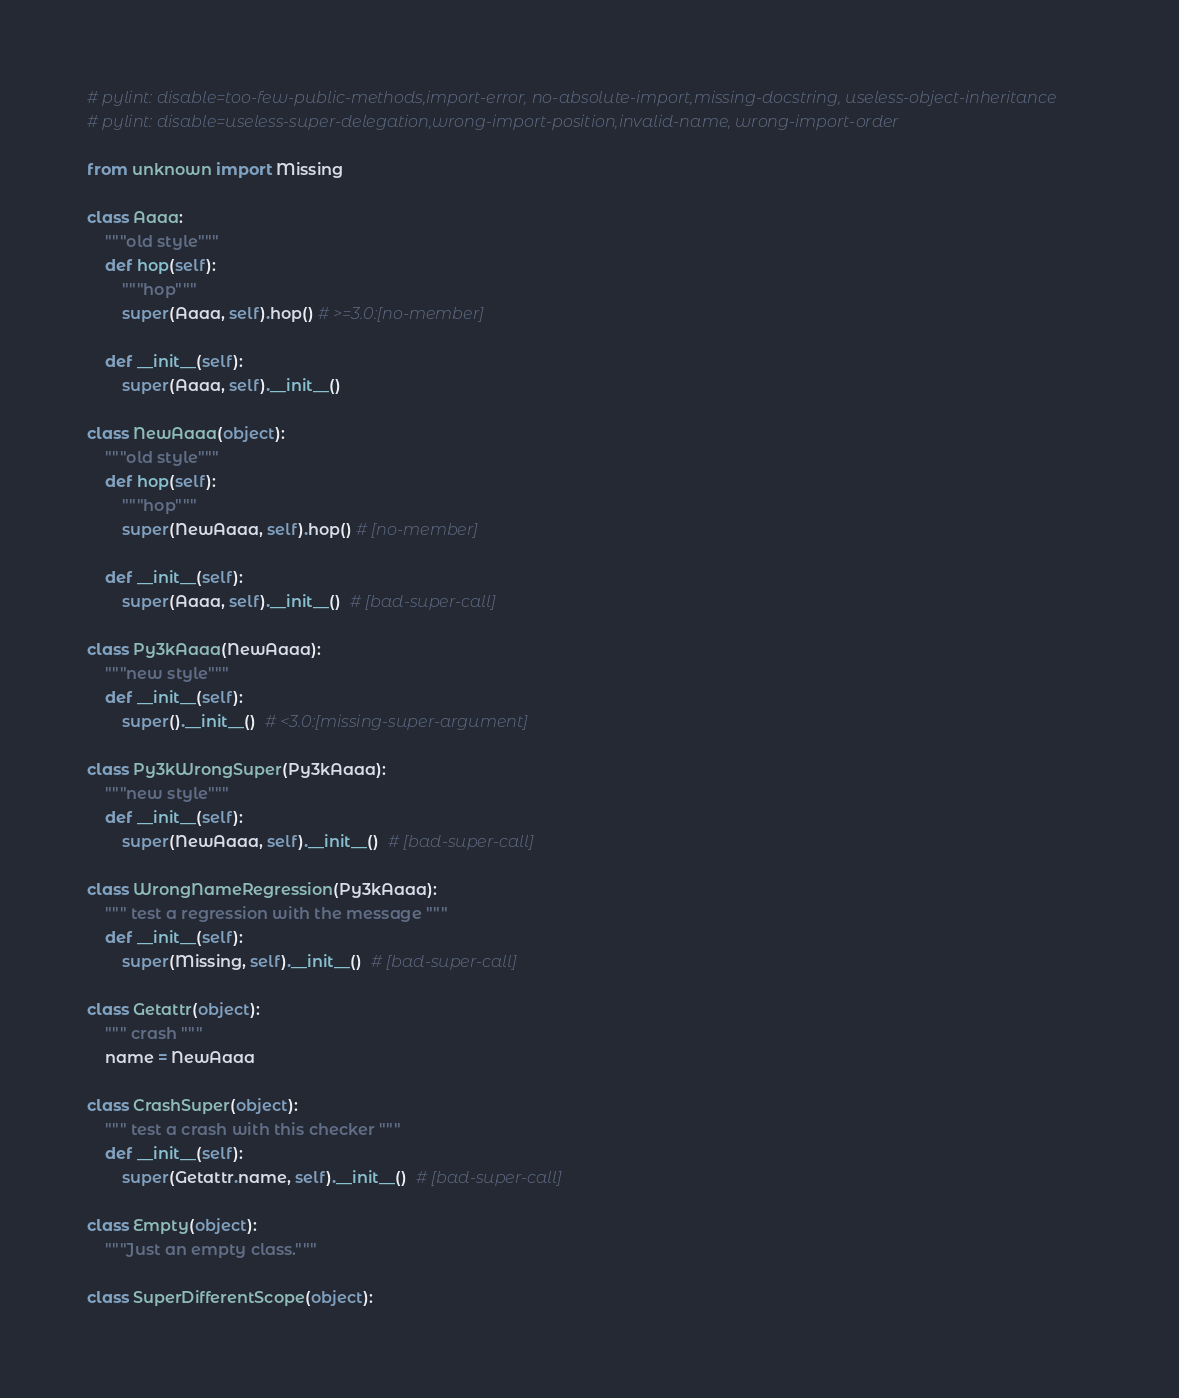<code> <loc_0><loc_0><loc_500><loc_500><_Python_># pylint: disable=too-few-public-methods,import-error, no-absolute-import,missing-docstring, useless-object-inheritance
# pylint: disable=useless-super-delegation,wrong-import-position,invalid-name, wrong-import-order

from unknown import Missing

class Aaaa:
    """old style"""
    def hop(self):
        """hop"""
        super(Aaaa, self).hop() # >=3.0:[no-member]

    def __init__(self):
        super(Aaaa, self).__init__()

class NewAaaa(object):
    """old style"""
    def hop(self):
        """hop"""
        super(NewAaaa, self).hop() # [no-member]

    def __init__(self):
        super(Aaaa, self).__init__()  # [bad-super-call]

class Py3kAaaa(NewAaaa):
    """new style"""
    def __init__(self):
        super().__init__()  # <3.0:[missing-super-argument]

class Py3kWrongSuper(Py3kAaaa):
    """new style"""
    def __init__(self):
        super(NewAaaa, self).__init__()  # [bad-super-call]

class WrongNameRegression(Py3kAaaa):
    """ test a regression with the message """
    def __init__(self):
        super(Missing, self).__init__()  # [bad-super-call]

class Getattr(object):
    """ crash """
    name = NewAaaa

class CrashSuper(object):
    """ test a crash with this checker """
    def __init__(self):
        super(Getattr.name, self).__init__()  # [bad-super-call]

class Empty(object):
    """Just an empty class."""

class SuperDifferentScope(object):</code> 